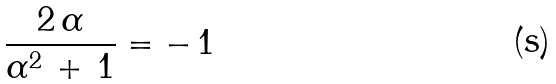Convert formula to latex. <formula><loc_0><loc_0><loc_500><loc_500>\frac { 2 \, \alpha } { \alpha ^ { 2 } \, + \, 1 } = - \, 1</formula> 